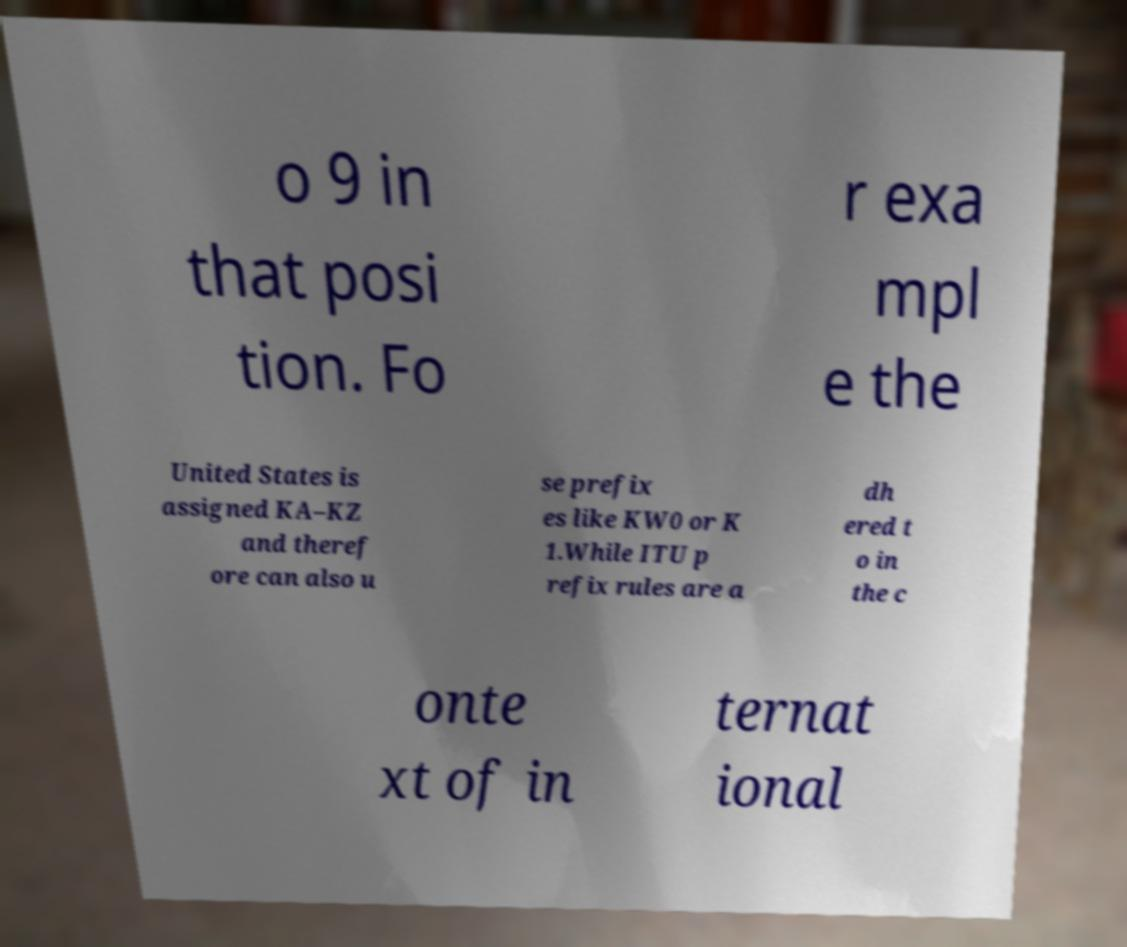What messages or text are displayed in this image? I need them in a readable, typed format. o 9 in that posi tion. Fo r exa mpl e the United States is assigned KA–KZ and theref ore can also u se prefix es like KW0 or K 1.While ITU p refix rules are a dh ered t o in the c onte xt of in ternat ional 